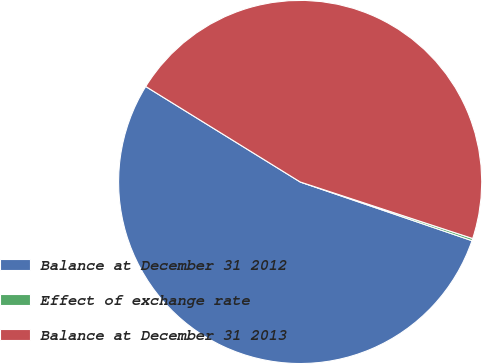Convert chart to OTSL. <chart><loc_0><loc_0><loc_500><loc_500><pie_chart><fcel>Balance at December 31 2012<fcel>Effect of exchange rate<fcel>Balance at December 31 2013<nl><fcel>53.57%<fcel>0.2%<fcel>46.23%<nl></chart> 